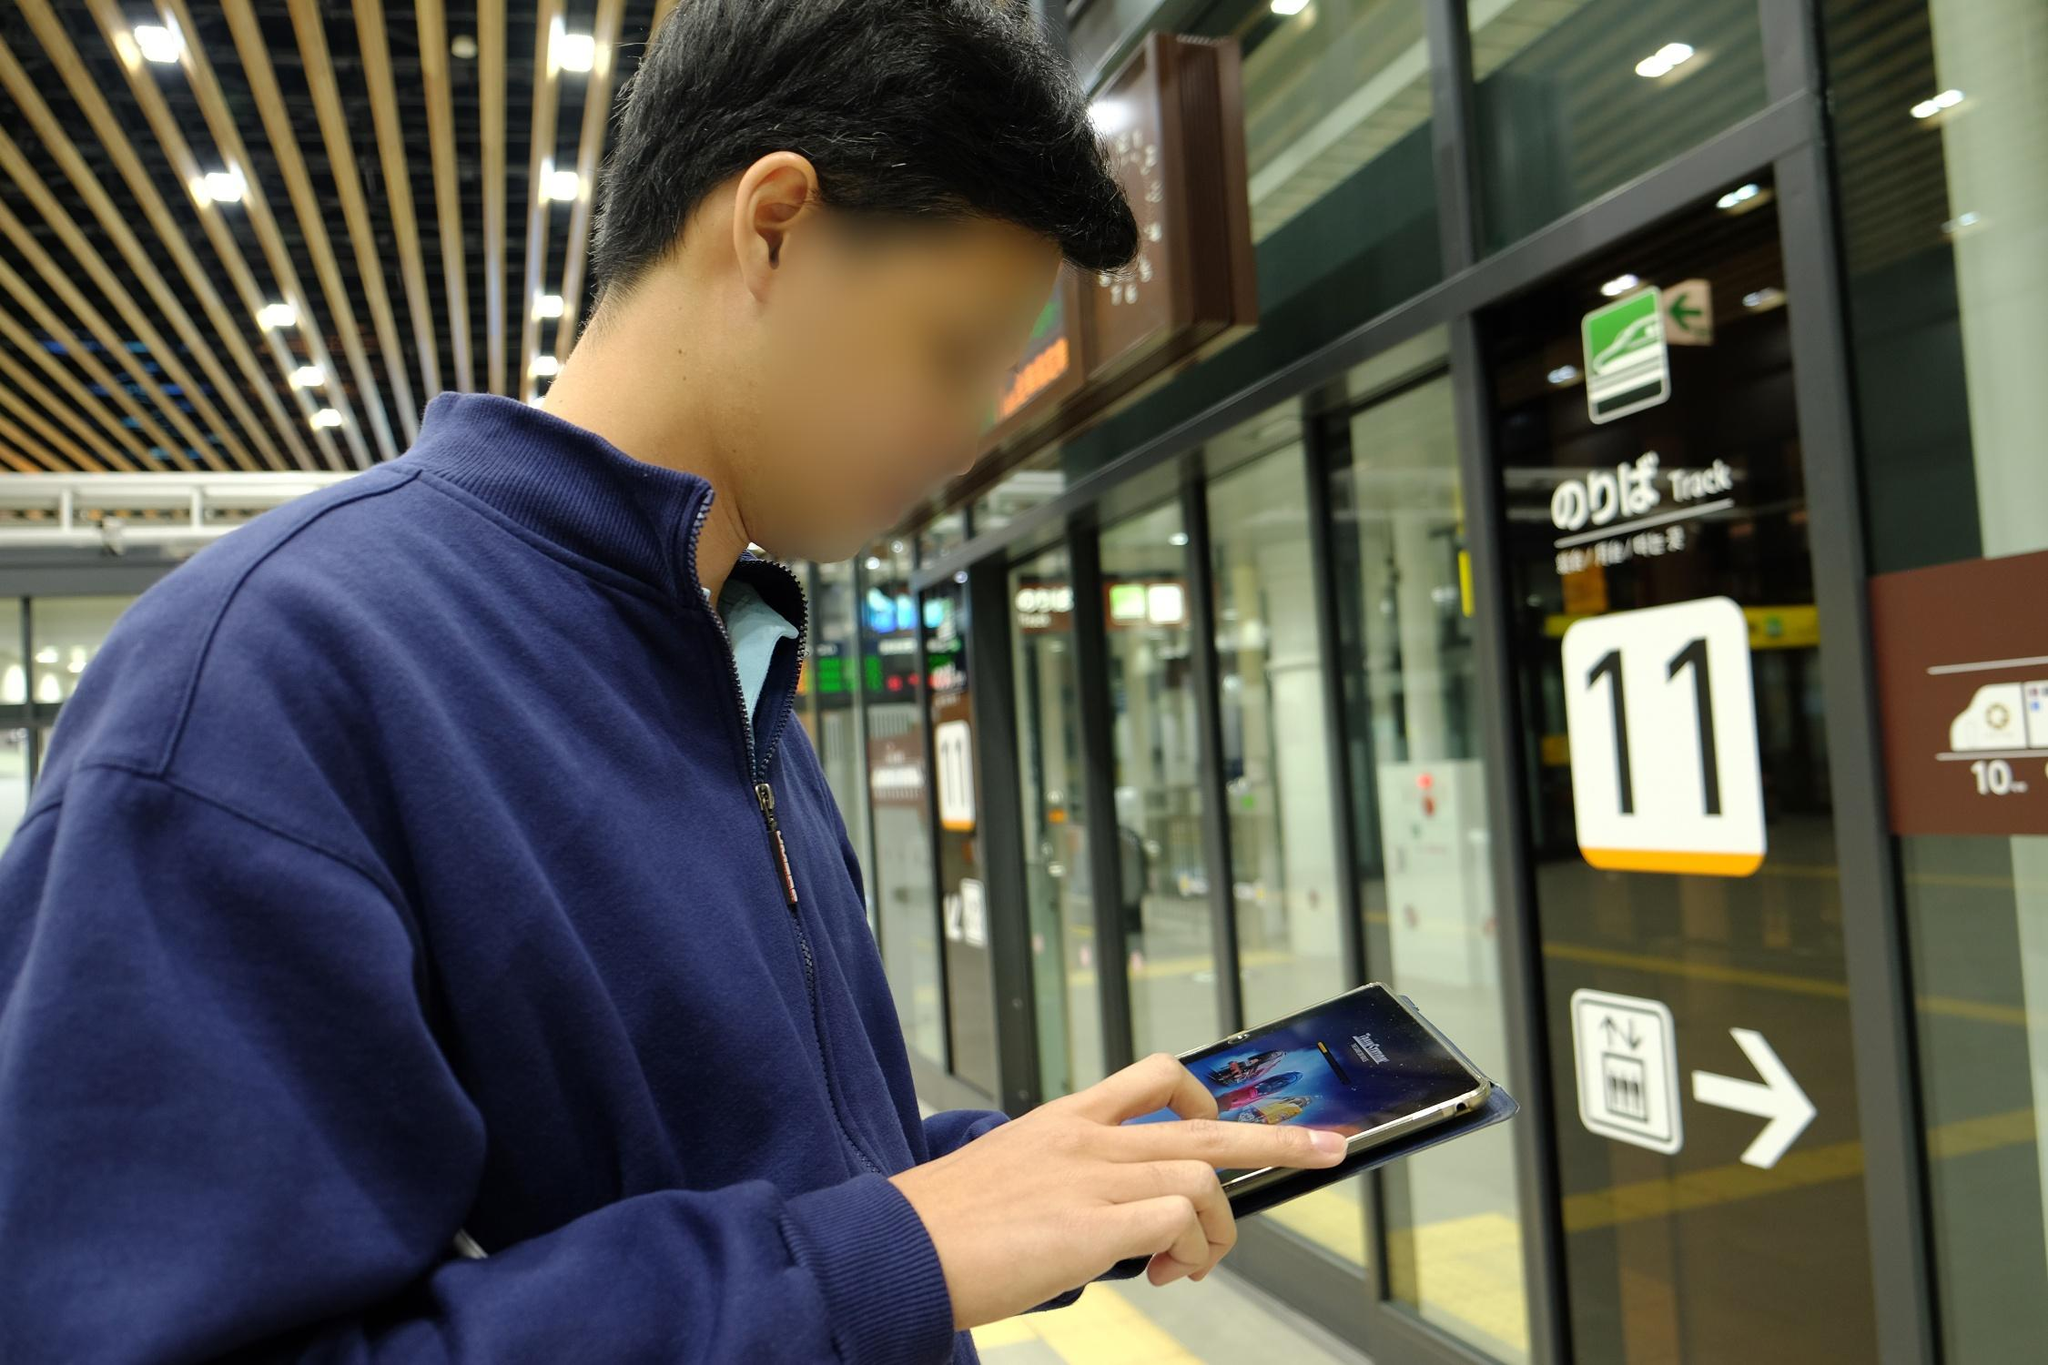Can you describe the main features of this image for me? The image seems to capture a moment at a modern train station. In the foreground, there's a person wearing a blue jacket who is focused on their phone, which displays a vivid image. The surrounding station is bustling with activity. Track 11 is particularly noticeable with a clear sign and directional arrow pointing towards it. The train platform, indicated with various information signs, is seen in the background. A distinct feature of the station is its ceiling, which comprises an artistic array of wooden slats, adding to its contemporary design. This scene beautifully juxtaposes the intimate focus on personal technology against the backdrop of urban public transportation. 